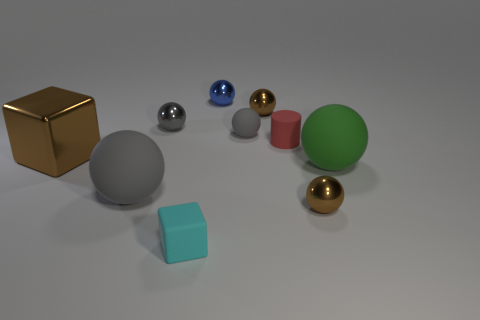Subtract all gray balls. How many were subtracted if there are1gray balls left? 2 Subtract all green rubber balls. How many balls are left? 6 Subtract all green cylinders. How many brown spheres are left? 2 Subtract all green balls. How many balls are left? 6 Subtract 5 balls. How many balls are left? 2 Subtract all cubes. How many objects are left? 8 Add 7 tiny gray balls. How many tiny gray balls exist? 9 Subtract 1 brown cubes. How many objects are left? 9 Subtract all gray spheres. Subtract all red cylinders. How many spheres are left? 4 Subtract all red cylinders. Subtract all tiny red cylinders. How many objects are left? 8 